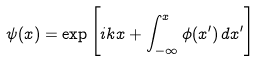<formula> <loc_0><loc_0><loc_500><loc_500>\psi ( x ) = \exp \Big { [ } i k x + \int _ { - \infty } ^ { x } \phi ( x ^ { \prime } ) \, d x ^ { \prime } \Big { ] }</formula> 